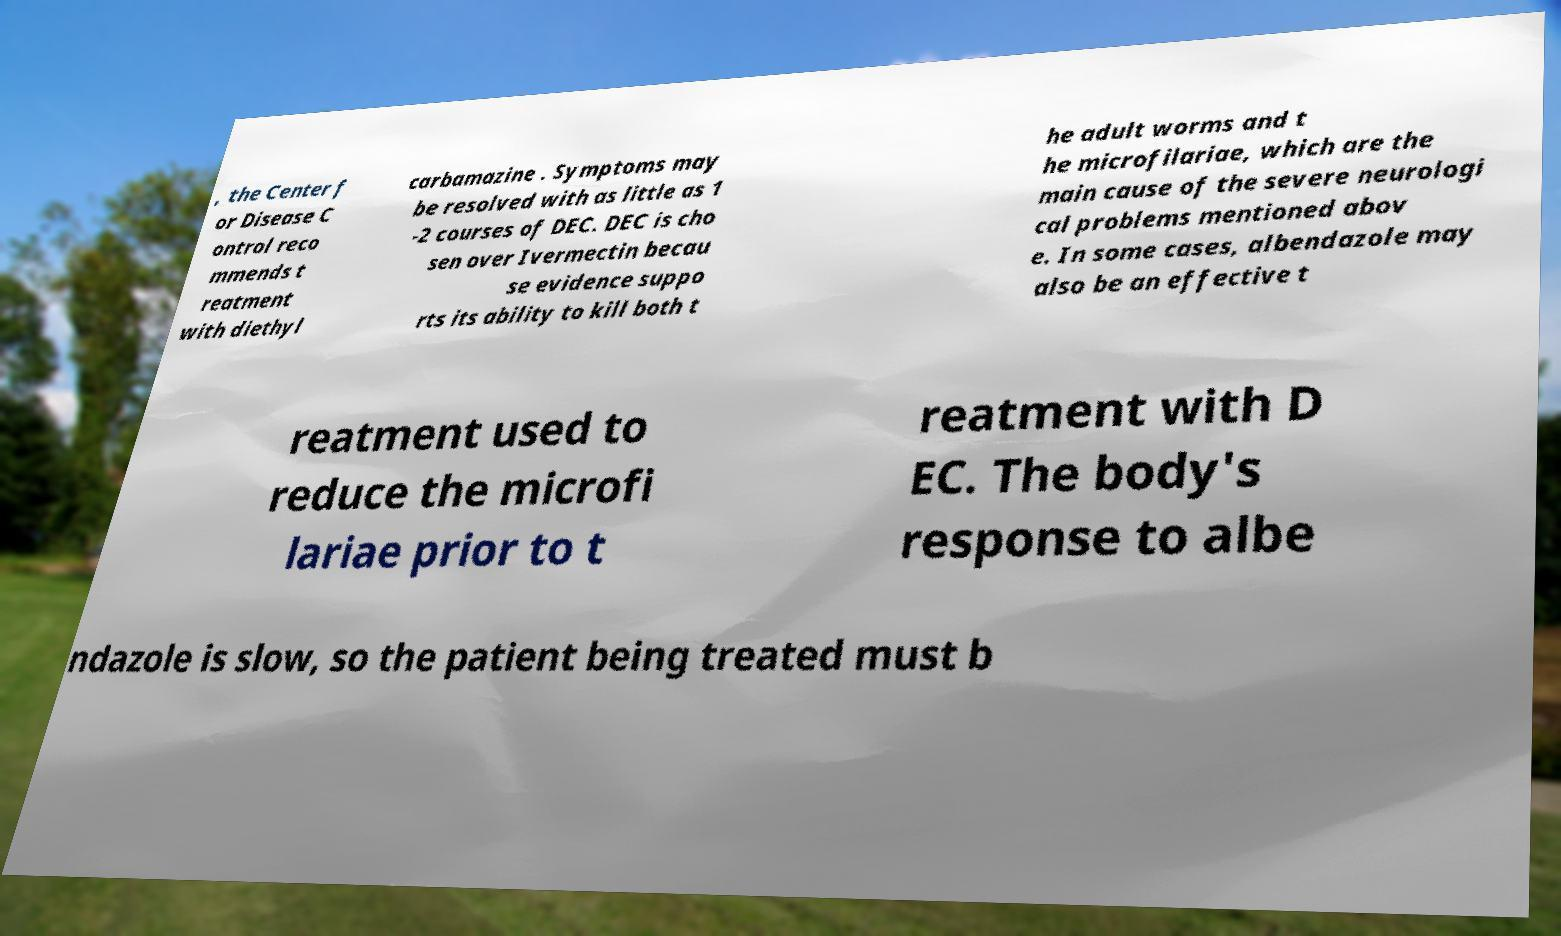There's text embedded in this image that I need extracted. Can you transcribe it verbatim? , the Center f or Disease C ontrol reco mmends t reatment with diethyl carbamazine . Symptoms may be resolved with as little as 1 -2 courses of DEC. DEC is cho sen over Ivermectin becau se evidence suppo rts its ability to kill both t he adult worms and t he microfilariae, which are the main cause of the severe neurologi cal problems mentioned abov e. In some cases, albendazole may also be an effective t reatment used to reduce the microfi lariae prior to t reatment with D EC. The body's response to albe ndazole is slow, so the patient being treated must b 